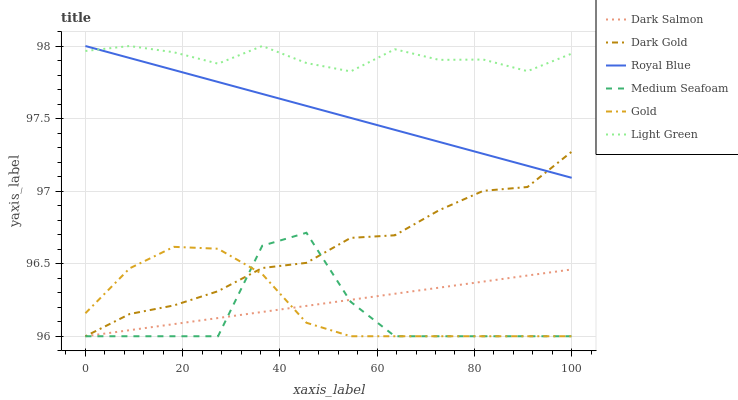Does Medium Seafoam have the minimum area under the curve?
Answer yes or no. Yes. Does Light Green have the maximum area under the curve?
Answer yes or no. Yes. Does Dark Gold have the minimum area under the curve?
Answer yes or no. No. Does Dark Gold have the maximum area under the curve?
Answer yes or no. No. Is Dark Salmon the smoothest?
Answer yes or no. Yes. Is Medium Seafoam the roughest?
Answer yes or no. Yes. Is Dark Gold the smoothest?
Answer yes or no. No. Is Dark Gold the roughest?
Answer yes or no. No. Does Gold have the lowest value?
Answer yes or no. Yes. Does Royal Blue have the lowest value?
Answer yes or no. No. Does Light Green have the highest value?
Answer yes or no. Yes. Does Dark Gold have the highest value?
Answer yes or no. No. Is Dark Salmon less than Royal Blue?
Answer yes or no. Yes. Is Light Green greater than Dark Gold?
Answer yes or no. Yes. Does Medium Seafoam intersect Dark Salmon?
Answer yes or no. Yes. Is Medium Seafoam less than Dark Salmon?
Answer yes or no. No. Is Medium Seafoam greater than Dark Salmon?
Answer yes or no. No. Does Dark Salmon intersect Royal Blue?
Answer yes or no. No. 